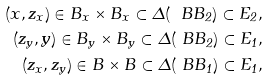Convert formula to latex. <formula><loc_0><loc_0><loc_500><loc_500>( x , z _ { x } ) \in B _ { x } \times B _ { x } \subset \Delta ( \ B B _ { 2 } ) \subset E _ { 2 } , \\ ( z _ { y } , y ) \in B _ { y } \times B _ { y } \subset \Delta ( \ B B _ { 2 } ) \subset E _ { 1 } , \\ ( z _ { x } , z _ { y } ) \in B \times B \subset \Delta ( \ B B _ { 1 } ) \subset E _ { 1 } ,</formula> 